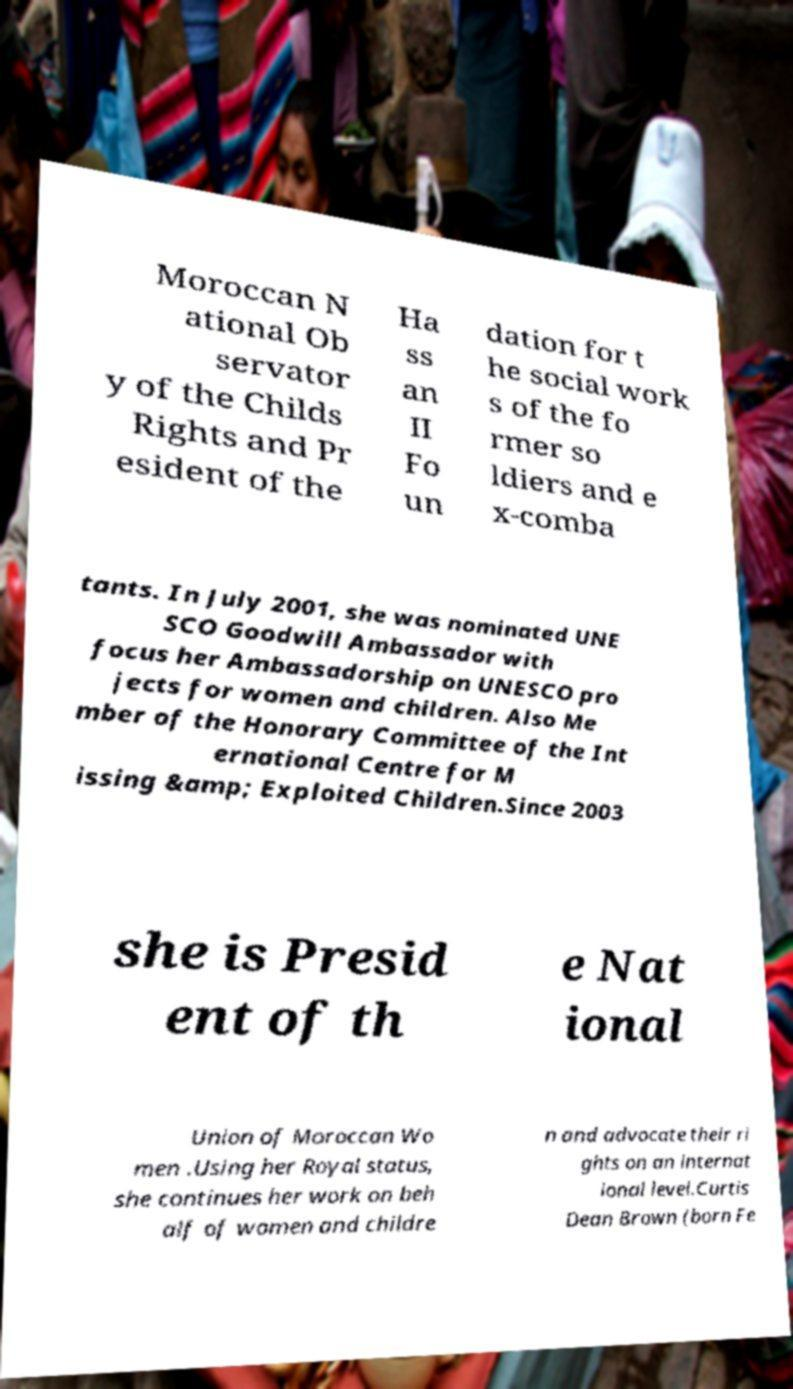I need the written content from this picture converted into text. Can you do that? Moroccan N ational Ob servator y of the Childs Rights and Pr esident of the Ha ss an II Fo un dation for t he social work s of the fo rmer so ldiers and e x-comba tants. In July 2001, she was nominated UNE SCO Goodwill Ambassador with focus her Ambassadorship on UNESCO pro jects for women and children. Also Me mber of the Honorary Committee of the Int ernational Centre for M issing &amp; Exploited Children.Since 2003 she is Presid ent of th e Nat ional Union of Moroccan Wo men .Using her Royal status, she continues her work on beh alf of women and childre n and advocate their ri ghts on an internat ional level.Curtis Dean Brown (born Fe 